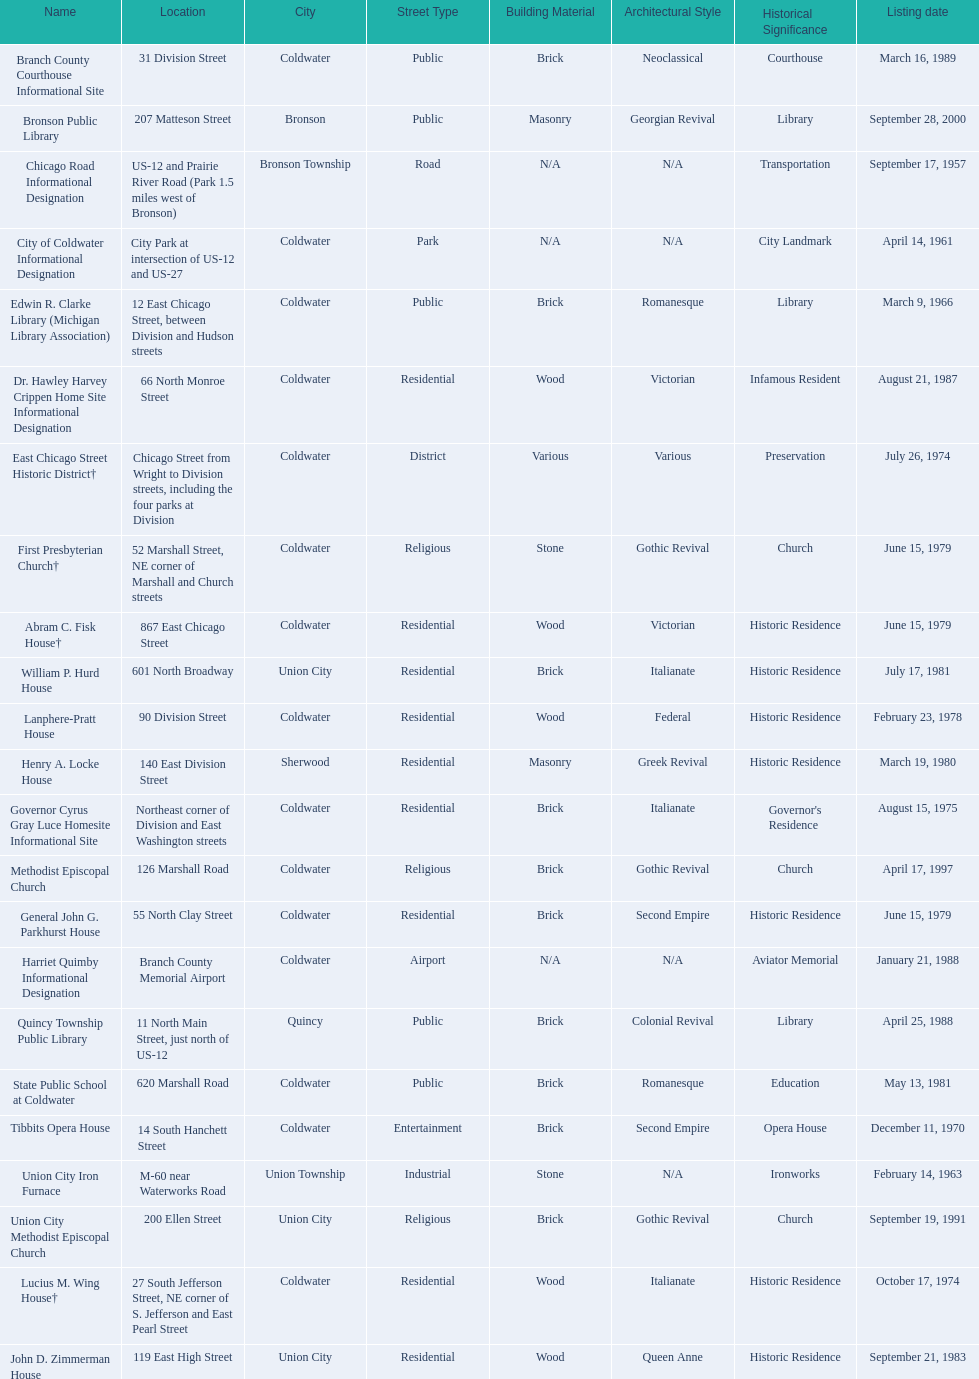Which city has the largest number of historic sites? Coldwater. 